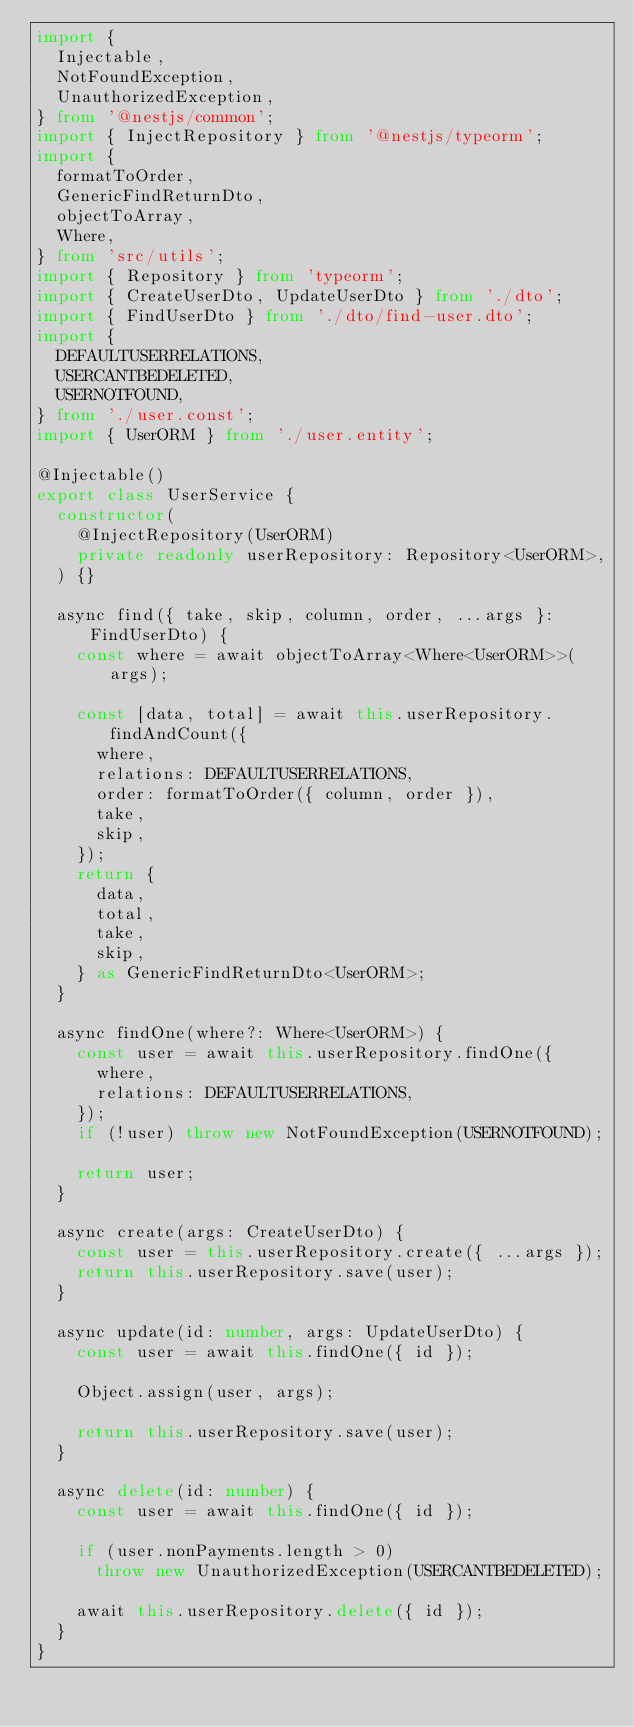<code> <loc_0><loc_0><loc_500><loc_500><_TypeScript_>import {
  Injectable,
  NotFoundException,
  UnauthorizedException,
} from '@nestjs/common';
import { InjectRepository } from '@nestjs/typeorm';
import {
  formatToOrder,
  GenericFindReturnDto,
  objectToArray,
  Where,
} from 'src/utils';
import { Repository } from 'typeorm';
import { CreateUserDto, UpdateUserDto } from './dto';
import { FindUserDto } from './dto/find-user.dto';
import {
  DEFAULTUSERRELATIONS,
  USERCANTBEDELETED,
  USERNOTFOUND,
} from './user.const';
import { UserORM } from './user.entity';

@Injectable()
export class UserService {
  constructor(
    @InjectRepository(UserORM)
    private readonly userRepository: Repository<UserORM>,
  ) {}

  async find({ take, skip, column, order, ...args }: FindUserDto) {
    const where = await objectToArray<Where<UserORM>>(args);

    const [data, total] = await this.userRepository.findAndCount({
      where,
      relations: DEFAULTUSERRELATIONS,
      order: formatToOrder({ column, order }),
      take,
      skip,
    });
    return {
      data,
      total,
      take,
      skip,
    } as GenericFindReturnDto<UserORM>;
  }

  async findOne(where?: Where<UserORM>) {
    const user = await this.userRepository.findOne({
      where,
      relations: DEFAULTUSERRELATIONS,
    });
    if (!user) throw new NotFoundException(USERNOTFOUND);

    return user;
  }

  async create(args: CreateUserDto) {
    const user = this.userRepository.create({ ...args });
    return this.userRepository.save(user);
  }

  async update(id: number, args: UpdateUserDto) {
    const user = await this.findOne({ id });

    Object.assign(user, args);

    return this.userRepository.save(user);
  }

  async delete(id: number) {
    const user = await this.findOne({ id });

    if (user.nonPayments.length > 0)
      throw new UnauthorizedException(USERCANTBEDELETED);

    await this.userRepository.delete({ id });
  }
}
</code> 